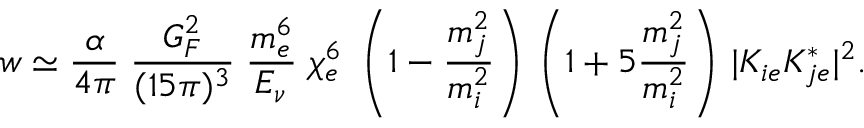Convert formula to latex. <formula><loc_0><loc_0><loc_500><loc_500>w \simeq { \frac { \alpha } { 4 \pi } } \, { \frac { G _ { F } ^ { 2 } } { ( 1 5 \pi ) ^ { 3 } } } \, \frac { m _ { e } ^ { 6 } } { E _ { \nu } } \, \chi _ { e } ^ { 6 } \, \left ( 1 - { \frac { m _ { j } ^ { 2 } } { m _ { i } ^ { 2 } } } \right ) \, \left ( 1 + 5 { \frac { m _ { j } ^ { 2 } } { m _ { i } ^ { 2 } } } \right ) \, | K _ { i e } K _ { j e } ^ { * } | ^ { 2 } .</formula> 